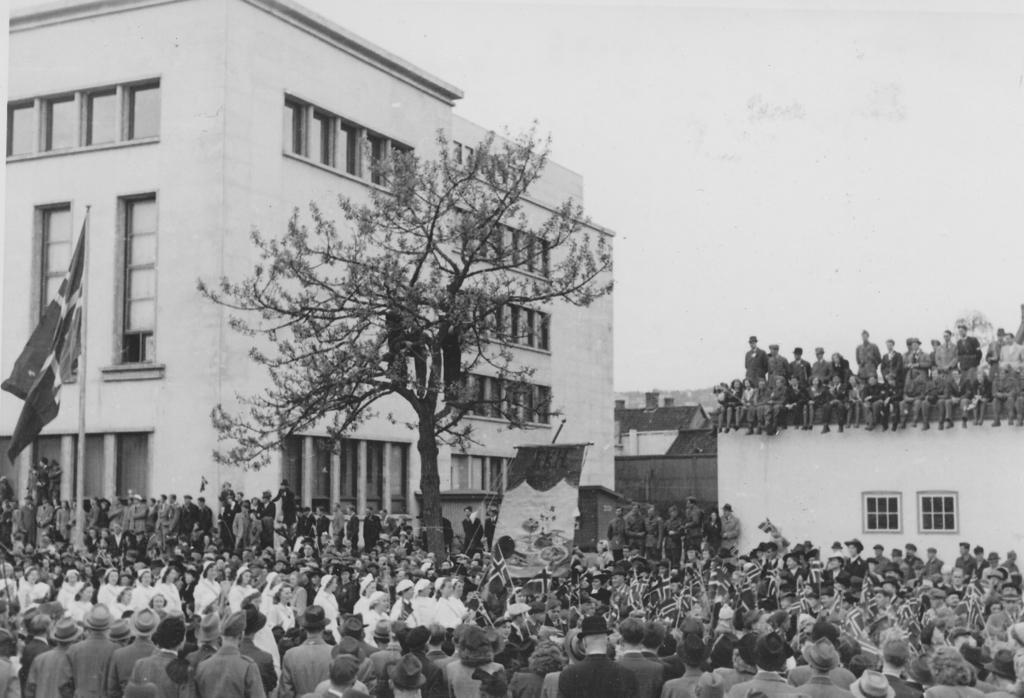Could you give a brief overview of what you see in this image? This is a black and white image. I can see the groups of people standing and sitting. These are the buildings with the windows. I can see a flag hanging to a pole. This is a tree. I think this is a banner. 